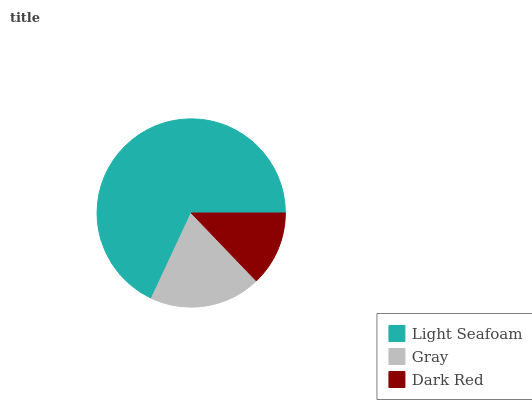Is Dark Red the minimum?
Answer yes or no. Yes. Is Light Seafoam the maximum?
Answer yes or no. Yes. Is Gray the minimum?
Answer yes or no. No. Is Gray the maximum?
Answer yes or no. No. Is Light Seafoam greater than Gray?
Answer yes or no. Yes. Is Gray less than Light Seafoam?
Answer yes or no. Yes. Is Gray greater than Light Seafoam?
Answer yes or no. No. Is Light Seafoam less than Gray?
Answer yes or no. No. Is Gray the high median?
Answer yes or no. Yes. Is Gray the low median?
Answer yes or no. Yes. Is Light Seafoam the high median?
Answer yes or no. No. Is Dark Red the low median?
Answer yes or no. No. 